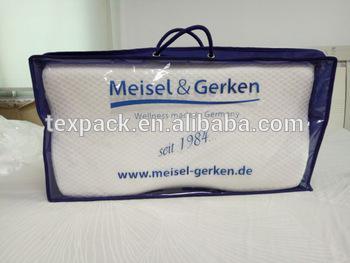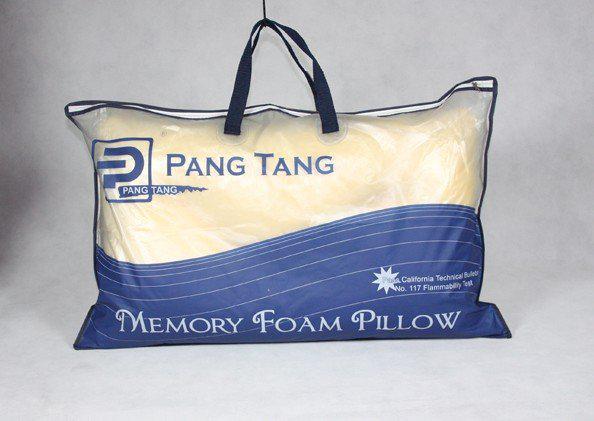The first image is the image on the left, the second image is the image on the right. Evaluate the accuracy of this statement regarding the images: "All four bags are translucent and stuffed tightly with a pillow.". Is it true? Answer yes or no. No. 